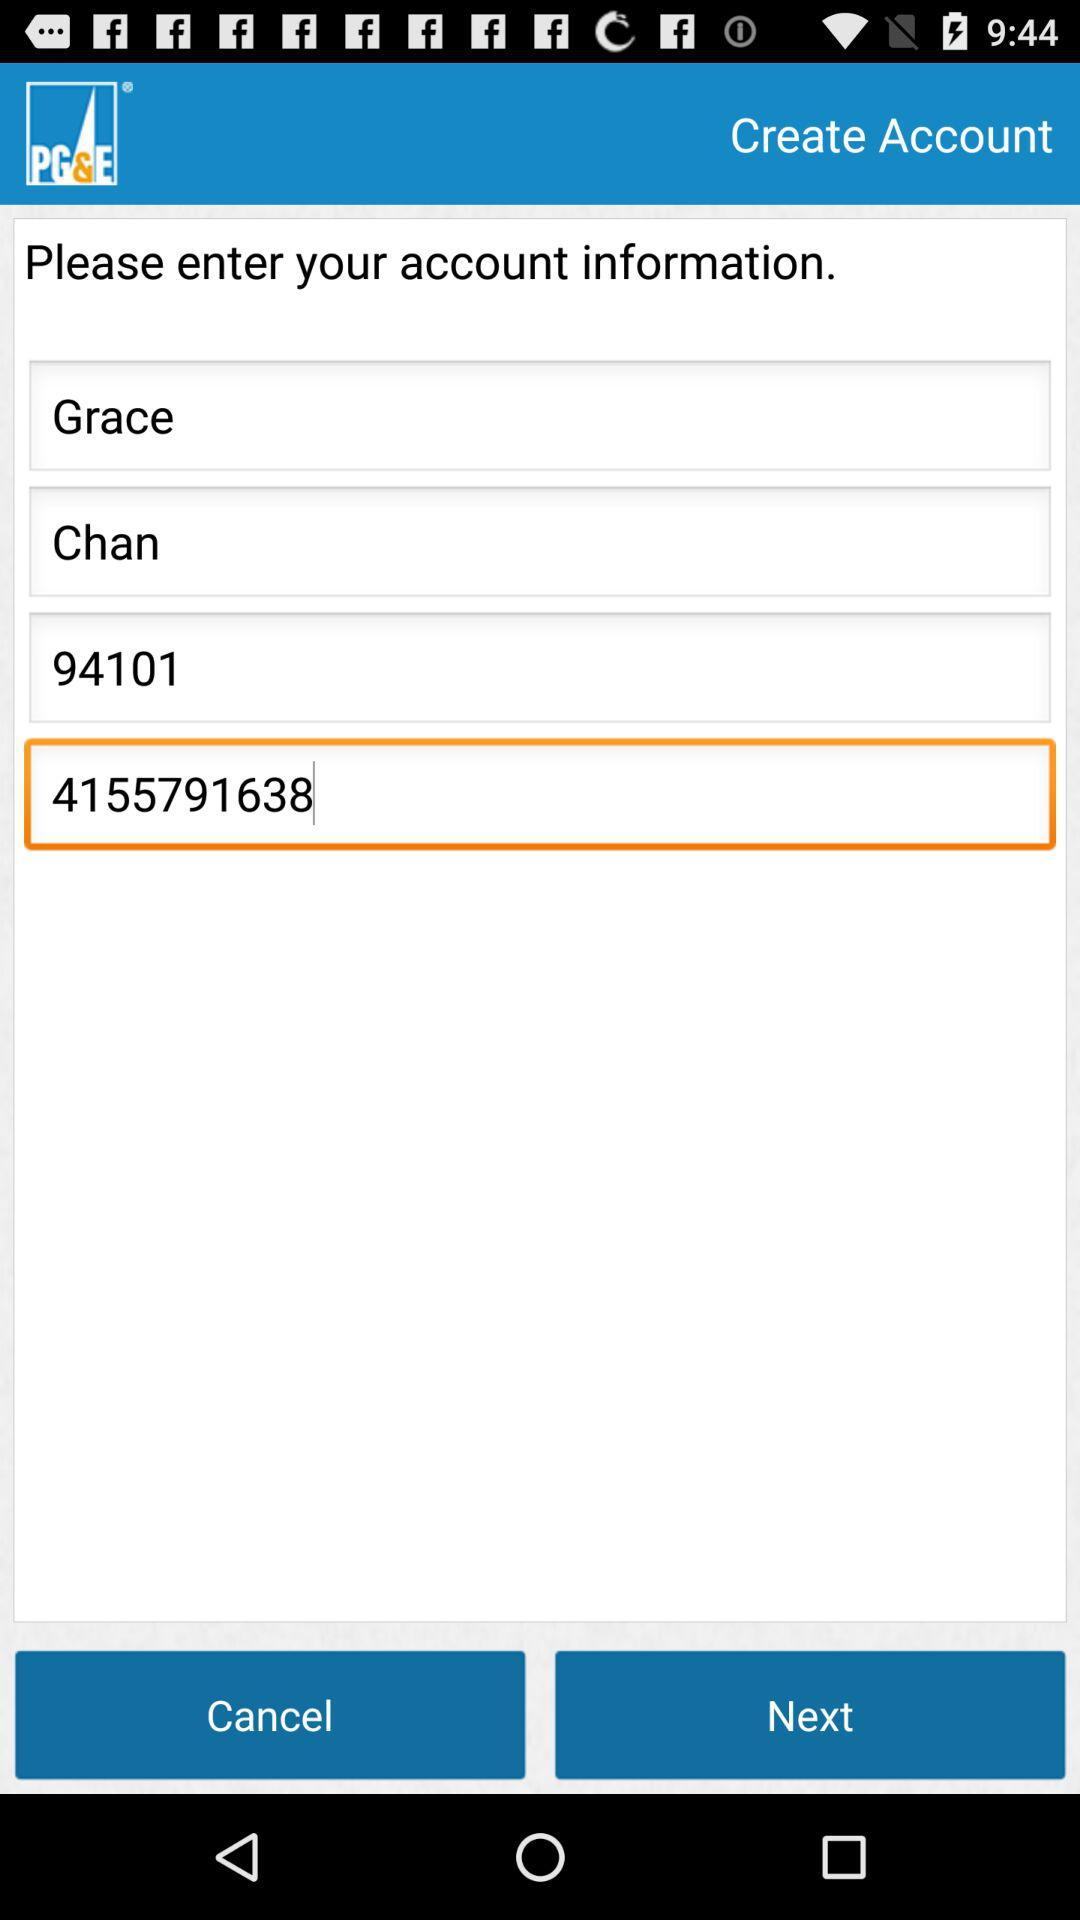How many digits are in the phone number input?
Answer the question using a single word or phrase. 10 